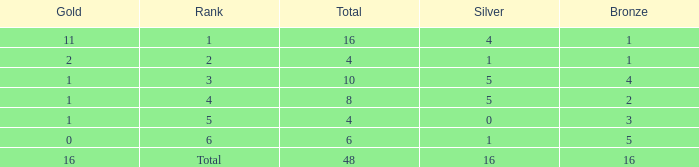What is the total gold that has bronze less than 2, a silver of 1 and total more than 4? None. 